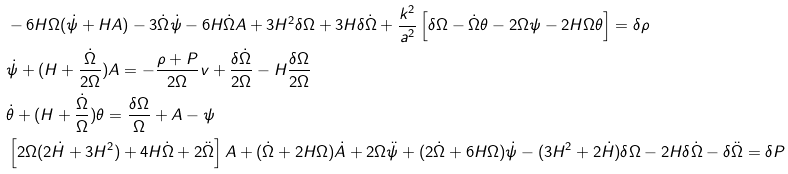<formula> <loc_0><loc_0><loc_500><loc_500>& - 6 H \Omega ( \dot { \psi } + H A ) - 3 \dot { \Omega } \dot { \psi } - 6 H \dot { \Omega } A + 3 H ^ { 2 } \delta \Omega + 3 H { \delta \dot { \Omega } } + \frac { k ^ { 2 } } { a ^ { 2 } } \left [ \delta \Omega - \dot { \Omega } \theta - 2 \Omega \psi - 2 H \Omega \theta \right ] = \delta \rho \\ & \dot { \psi } + ( H + \frac { \dot { \Omega } } { 2 \Omega } ) A = - \frac { \rho + P } { 2 \Omega } v + \frac { \delta \dot { \Omega } } { 2 \Omega } - H \frac { \delta \Omega } { 2 \Omega } \\ & \dot { \theta } + ( H + \frac { \dot { \Omega } } { \Omega } ) \theta = \frac { \delta \Omega } { \Omega } + A - \psi \\ & \left [ 2 \Omega ( 2 \dot { H } + 3 H ^ { 2 } ) + 4 H \dot { \Omega } + 2 \ddot { \Omega } \right ] A + ( \dot { \Omega } + 2 H \Omega ) \dot { A } + 2 \Omega \ddot { \psi } + ( 2 \dot { \Omega } + 6 H \Omega ) \dot { \psi } - ( 3 H ^ { 2 } + 2 \dot { H } ) \delta \Omega - 2 H \delta \dot { \Omega } - \delta \ddot { \Omega } = \delta P</formula> 